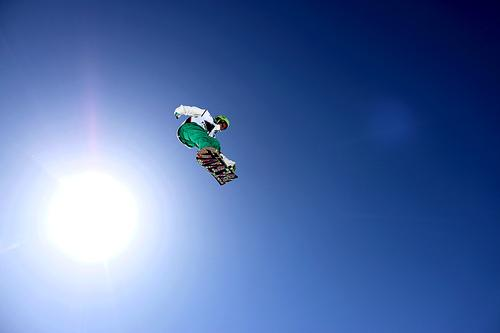How many suns are there in this image and how would you describe their appearance? There is one sun in the image, described as bright yellow, with rays and aura, and bright sunlight. Describe any safety gear the snowboarder is wearing and its colors. The snowboarder is wearing a green safety helmet, lime green crash helmet, black and orange safety glasses, and green strap on the helmet. Identify and provide a brief description of the main subject in the image and their surroundings. The main subject is a snowboarder doing various tricks in mid-air, surrounded by a clear blue sky and a bright sun. Identify and describe the main object in the sky. The main object in the sky is a bright yellow sun with rays and aura, projecting a spot of bright sunlight. Explain the color and appearance of the sky in this image. The sky is clear, blue, cloudless, deep blue, and bright, appearing consistently clear and bright throughout the image. Explain the overall sentiment or emotion that the image evokes. The image evokes excitement, adventure, and thrill, as the snowboarder is performing daring stunts in the air against a bright and clear sky. List the activities the snowboarder is performing in the image. The snowboarder is flying, jumping, doing tricks, and performing an incredibly high jump in the air. Determine the prominent colors in the snowboarder's outfit and gear. The prominent colors in the snowboarder's outfit are green, white, and black, with additional orange accents in the safety glasses. Please provide a count and description of items the snowboarder is wearing. The snowboarder is wearing goggles, green safety helmet, bulky white parka, green snow pants, white snow gloves, green strap, and a design on the front of the shirt. (7 items) Briefly describe the quality of the image, including any recognizable details. The image seems to be of good quality, with clear and recognisable details such as the snowboarder's outfit, facial features, and the vivid colors of the sun and sky. 